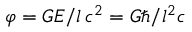<formula> <loc_0><loc_0><loc_500><loc_500>\varphi = G E / l \, c ^ { 2 } = G \hbar { / } l ^ { 2 } c</formula> 